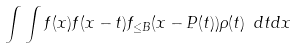Convert formula to latex. <formula><loc_0><loc_0><loc_500><loc_500>\int \int f ( x ) f ( x - t ) f _ { \leq B } ( x - P ( t ) ) \rho ( t ) \ d t d x</formula> 